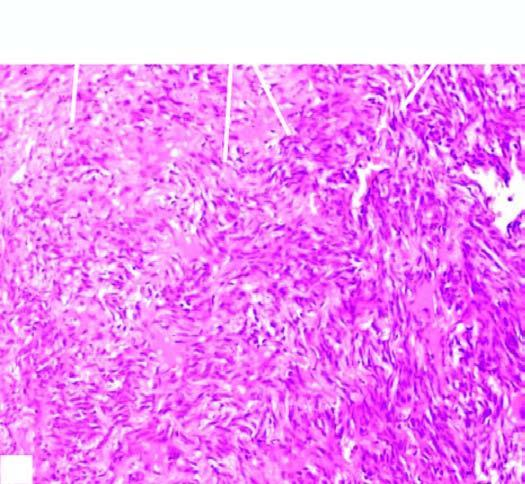what does sectioned surface of the lung show?
Answer the question using a single word or phrase. Replacement of slaty-grey spongy parenchyma 